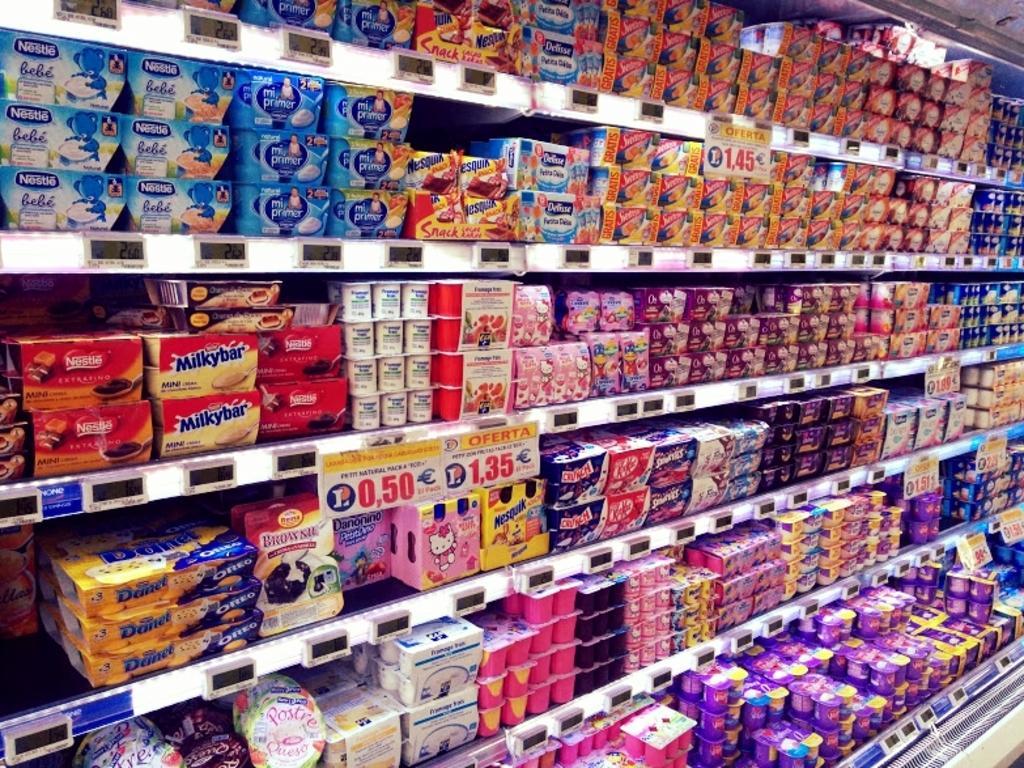How would you summarize this image in a sentence or two? Here in this picture we can see all edible items present in the racks and we can also see price boards present in the front on the racks. 